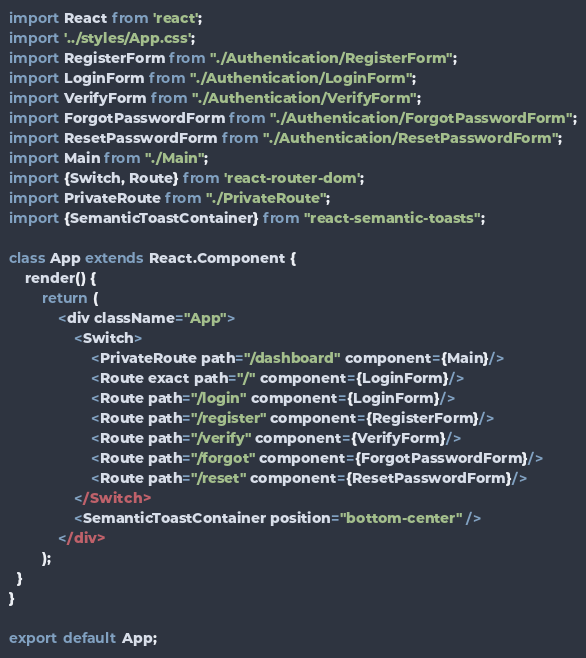Convert code to text. <code><loc_0><loc_0><loc_500><loc_500><_JavaScript_>import React from 'react';
import '../styles/App.css';
import RegisterForm from "./Authentication/RegisterForm";
import LoginForm from "./Authentication/LoginForm";
import VerifyForm from "./Authentication/VerifyForm";
import ForgotPasswordForm from "./Authentication/ForgotPasswordForm";
import ResetPasswordForm from "./Authentication/ResetPasswordForm";
import Main from "./Main";
import {Switch, Route} from 'react-router-dom';
import PrivateRoute from "./PrivateRoute";
import {SemanticToastContainer} from "react-semantic-toasts";

class App extends React.Component {
    render() {
        return (
            <div className="App">
                <Switch>
                    <PrivateRoute path="/dashboard" component={Main}/>
                    <Route exact path="/" component={LoginForm}/>
                    <Route path="/login" component={LoginForm}/>
                    <Route path="/register" component={RegisterForm}/>
                    <Route path="/verify" component={VerifyForm}/>
                    <Route path="/forgot" component={ForgotPasswordForm}/>
                    <Route path="/reset" component={ResetPasswordForm}/>
                </Switch>
                <SemanticToastContainer position="bottom-center" />
            </div>
        );
  }
}

export default App;
</code> 